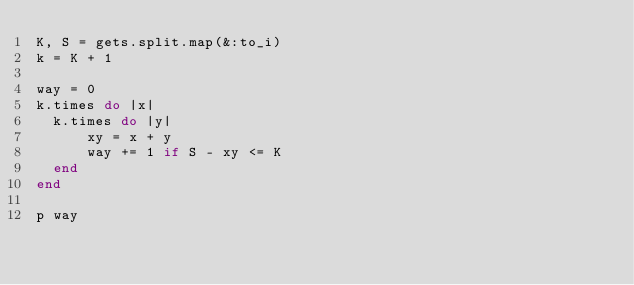Convert code to text. <code><loc_0><loc_0><loc_500><loc_500><_Ruby_>K, S = gets.split.map(&:to_i)
k = K + 1

way = 0
k.times do |x|
  k.times do |y|
      xy = x + y
      way += 1 if S - xy <= K
  end
end

p way</code> 